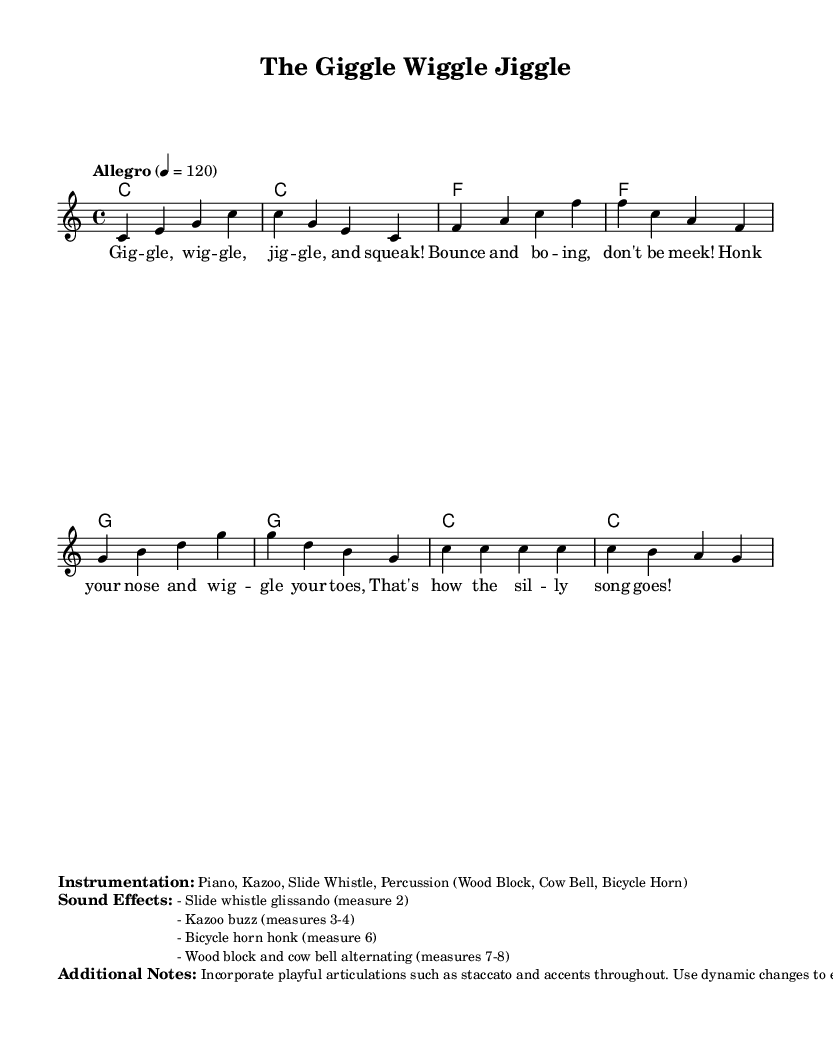What is the key signature of this music? The key signature is C major, which has no sharps or flats indicated on the staff.
Answer: C major What is the time signature of this music? The time signature is indicated at the beginning of the score and is 4/4, which means there are four beats in each measure.
Answer: 4/4 What is the tempo marking for this song? The tempo marking is specified in the score and denotes that the piece should be played "Allegro" at a speed of 120 beats per minute.
Answer: Allegro 4 = 120 How many measures are present in the melody? By counting each group of notes separated by vertical lines (bar lines), there are a total of eight measures in the melody section.
Answer: 8 What instrumentation is suggested for this piece? The instrumentation is listed in the markup section, specifying the instruments to be used for performance including Piano, Kazoo, Slide Whistle, and Percussion instruments.
Answer: Piano, Kazoo, Slide Whistle, Percussion What silly sound effects are specified in this music? The specified sound effects are listed in the markup section, detailing specific measures where different effects like slide whistle and kazoo should be used.
Answer: Slide whistle, Kazoo, Bicycle horn, Wood block, Cow Bell 